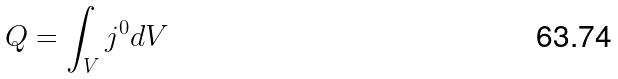Convert formula to latex. <formula><loc_0><loc_0><loc_500><loc_500>Q = \int _ { V } j ^ { 0 } d V</formula> 